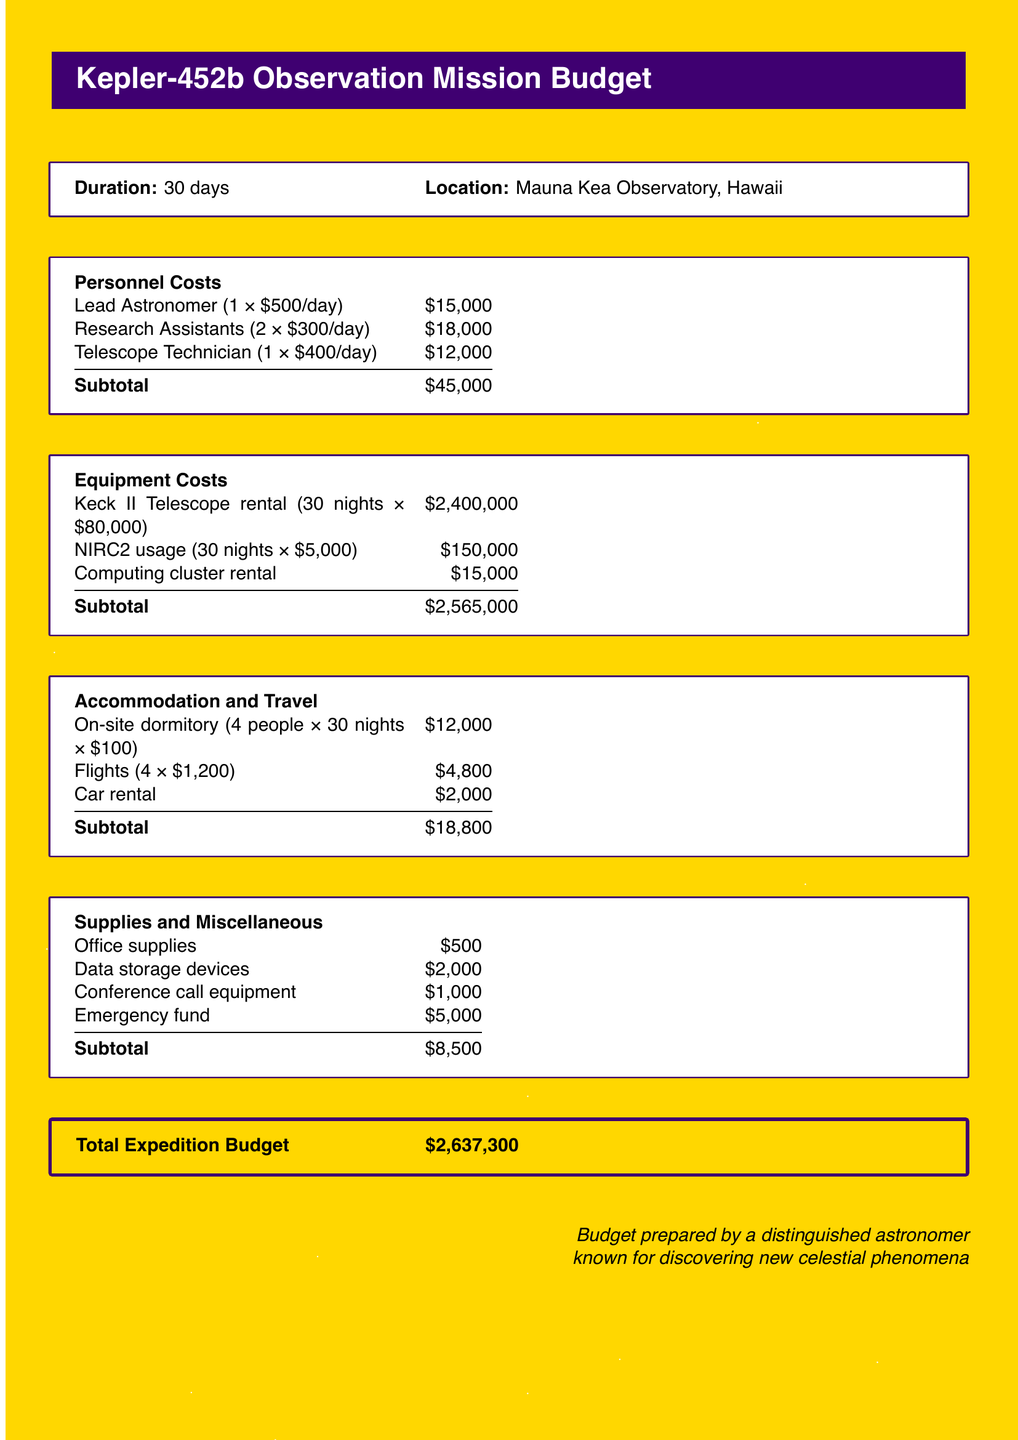what is the total expedition budget? The total expedition budget is calculated by summing all the subtotals in the document, which amounts to $2,637,300.
Answer: $2,637,300 how many research assistants are included? The personnel costs section specifies that there are 2 research assistants involved in the expedition.
Answer: 2 what is the rental cost for the Keck II Telescope? The budget details that the rental cost for the Keck II Telescope is $80,000 per night for 30 nights, totaling $2,400,000.
Answer: $2,400,000 how much is allocated for emergency funds? The supplies and miscellaneous section lists an emergency fund of $5,000 as part of the overall budget for the expedition.
Answer: $5,000 what is the duration of the expedition? The document states that the duration of the expedition is 30 days.
Answer: 30 days what are the total accommodation costs? The accommodation and travel section includes on-site dormitory, flights, and car rental, totaling $18,800 for accommodations and travel-related expenses.
Answer: $18,800 who prepared the budget? The budget is noted to have been prepared by a distinguished astronomer known for discovering new celestial phenomena.
Answer: a distinguished astronomer what is the daily cost for the Lead Astronomer? The personnel costs section indicates that the Lead Astronomer is paid $500 each day for their work on the expedition.
Answer: $500 how much is allocated for office supplies? The supplies and miscellaneous section specifies $500 allocated for office supplies in the budget.
Answer: $500 